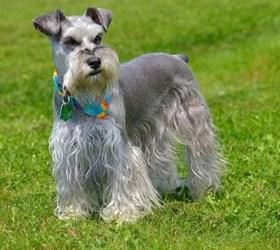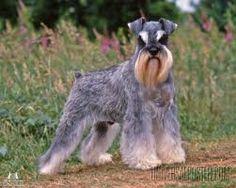The first image is the image on the left, the second image is the image on the right. Examine the images to the left and right. Is the description "A schnauzer on a leash is in profile facing leftward in front of some type of white lattice." accurate? Answer yes or no. No. The first image is the image on the left, the second image is the image on the right. Evaluate the accuracy of this statement regarding the images: "The dog in the image on the right is standing up on all four.". Is it true? Answer yes or no. Yes. 